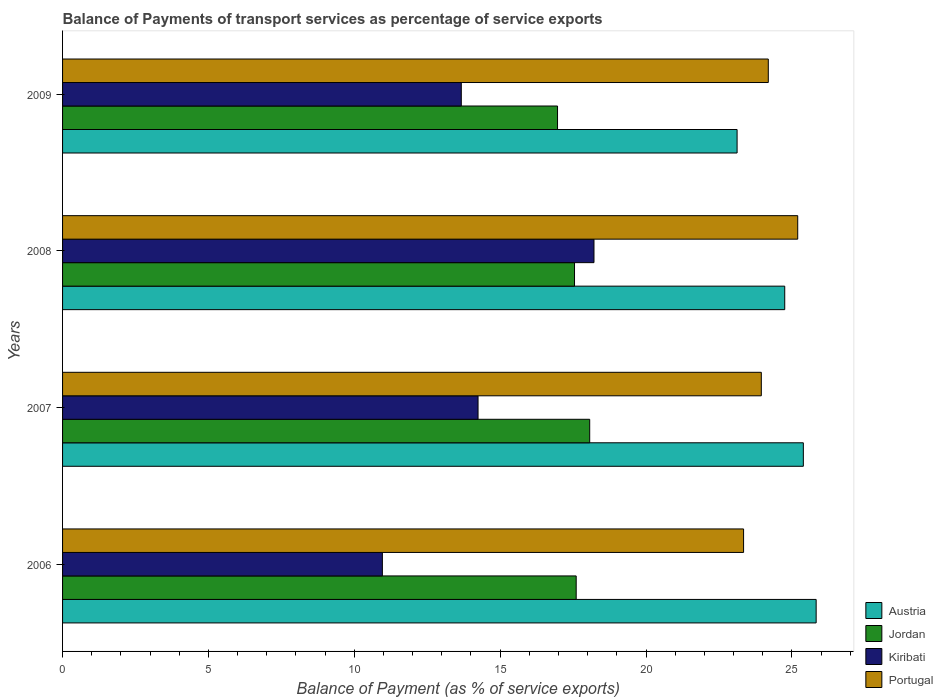Are the number of bars per tick equal to the number of legend labels?
Keep it short and to the point. Yes. Are the number of bars on each tick of the Y-axis equal?
Provide a short and direct response. Yes. How many bars are there on the 3rd tick from the top?
Give a very brief answer. 4. How many bars are there on the 4th tick from the bottom?
Ensure brevity in your answer.  4. What is the label of the 3rd group of bars from the top?
Make the answer very short. 2007. In how many cases, is the number of bars for a given year not equal to the number of legend labels?
Your answer should be compact. 0. What is the balance of payments of transport services in Jordan in 2006?
Provide a succinct answer. 17.61. Across all years, what is the maximum balance of payments of transport services in Austria?
Ensure brevity in your answer.  25.83. Across all years, what is the minimum balance of payments of transport services in Jordan?
Make the answer very short. 16.97. In which year was the balance of payments of transport services in Portugal minimum?
Keep it short and to the point. 2006. What is the total balance of payments of transport services in Portugal in the graph?
Ensure brevity in your answer.  96.69. What is the difference between the balance of payments of transport services in Jordan in 2006 and that in 2008?
Keep it short and to the point. 0.06. What is the difference between the balance of payments of transport services in Austria in 2006 and the balance of payments of transport services in Kiribati in 2007?
Provide a short and direct response. 11.59. What is the average balance of payments of transport services in Jordan per year?
Provide a short and direct response. 17.55. In the year 2009, what is the difference between the balance of payments of transport services in Jordan and balance of payments of transport services in Portugal?
Make the answer very short. -7.22. What is the ratio of the balance of payments of transport services in Kiribati in 2006 to that in 2009?
Give a very brief answer. 0.8. Is the difference between the balance of payments of transport services in Jordan in 2008 and 2009 greater than the difference between the balance of payments of transport services in Portugal in 2008 and 2009?
Make the answer very short. No. What is the difference between the highest and the second highest balance of payments of transport services in Jordan?
Your answer should be very brief. 0.46. What is the difference between the highest and the lowest balance of payments of transport services in Portugal?
Ensure brevity in your answer.  1.86. Is it the case that in every year, the sum of the balance of payments of transport services in Portugal and balance of payments of transport services in Austria is greater than the sum of balance of payments of transport services in Jordan and balance of payments of transport services in Kiribati?
Provide a succinct answer. No. What does the 1st bar from the top in 2008 represents?
Your response must be concise. Portugal. What does the 3rd bar from the bottom in 2008 represents?
Your answer should be compact. Kiribati. Is it the case that in every year, the sum of the balance of payments of transport services in Austria and balance of payments of transport services in Jordan is greater than the balance of payments of transport services in Kiribati?
Give a very brief answer. Yes. How many bars are there?
Offer a terse response. 16. Are all the bars in the graph horizontal?
Make the answer very short. Yes. What is the difference between two consecutive major ticks on the X-axis?
Your answer should be compact. 5. Where does the legend appear in the graph?
Your answer should be compact. Bottom right. How are the legend labels stacked?
Your answer should be very brief. Vertical. What is the title of the graph?
Provide a short and direct response. Balance of Payments of transport services as percentage of service exports. Does "Sao Tome and Principe" appear as one of the legend labels in the graph?
Your answer should be compact. No. What is the label or title of the X-axis?
Offer a very short reply. Balance of Payment (as % of service exports). What is the Balance of Payment (as % of service exports) in Austria in 2006?
Offer a very short reply. 25.83. What is the Balance of Payment (as % of service exports) in Jordan in 2006?
Provide a short and direct response. 17.61. What is the Balance of Payment (as % of service exports) in Kiribati in 2006?
Provide a succinct answer. 10.96. What is the Balance of Payment (as % of service exports) of Portugal in 2006?
Your answer should be very brief. 23.34. What is the Balance of Payment (as % of service exports) of Austria in 2007?
Ensure brevity in your answer.  25.39. What is the Balance of Payment (as % of service exports) in Jordan in 2007?
Offer a very short reply. 18.07. What is the Balance of Payment (as % of service exports) in Kiribati in 2007?
Offer a terse response. 14.24. What is the Balance of Payment (as % of service exports) of Portugal in 2007?
Provide a short and direct response. 23.95. What is the Balance of Payment (as % of service exports) of Austria in 2008?
Offer a terse response. 24.75. What is the Balance of Payment (as % of service exports) in Jordan in 2008?
Give a very brief answer. 17.55. What is the Balance of Payment (as % of service exports) in Kiribati in 2008?
Your answer should be compact. 18.22. What is the Balance of Payment (as % of service exports) of Portugal in 2008?
Make the answer very short. 25.2. What is the Balance of Payment (as % of service exports) in Austria in 2009?
Offer a terse response. 23.12. What is the Balance of Payment (as % of service exports) in Jordan in 2009?
Provide a succinct answer. 16.97. What is the Balance of Payment (as % of service exports) in Kiribati in 2009?
Provide a short and direct response. 13.67. What is the Balance of Payment (as % of service exports) in Portugal in 2009?
Provide a succinct answer. 24.19. Across all years, what is the maximum Balance of Payment (as % of service exports) of Austria?
Ensure brevity in your answer.  25.83. Across all years, what is the maximum Balance of Payment (as % of service exports) of Jordan?
Your answer should be compact. 18.07. Across all years, what is the maximum Balance of Payment (as % of service exports) in Kiribati?
Ensure brevity in your answer.  18.22. Across all years, what is the maximum Balance of Payment (as % of service exports) in Portugal?
Keep it short and to the point. 25.2. Across all years, what is the minimum Balance of Payment (as % of service exports) in Austria?
Keep it short and to the point. 23.12. Across all years, what is the minimum Balance of Payment (as % of service exports) in Jordan?
Offer a terse response. 16.97. Across all years, what is the minimum Balance of Payment (as % of service exports) in Kiribati?
Ensure brevity in your answer.  10.96. Across all years, what is the minimum Balance of Payment (as % of service exports) in Portugal?
Make the answer very short. 23.34. What is the total Balance of Payment (as % of service exports) in Austria in the graph?
Keep it short and to the point. 99.1. What is the total Balance of Payment (as % of service exports) in Jordan in the graph?
Your answer should be compact. 70.19. What is the total Balance of Payment (as % of service exports) in Kiribati in the graph?
Ensure brevity in your answer.  57.09. What is the total Balance of Payment (as % of service exports) of Portugal in the graph?
Offer a very short reply. 96.69. What is the difference between the Balance of Payment (as % of service exports) of Austria in 2006 and that in 2007?
Your answer should be compact. 0.44. What is the difference between the Balance of Payment (as % of service exports) in Jordan in 2006 and that in 2007?
Make the answer very short. -0.46. What is the difference between the Balance of Payment (as % of service exports) in Kiribati in 2006 and that in 2007?
Keep it short and to the point. -3.28. What is the difference between the Balance of Payment (as % of service exports) in Portugal in 2006 and that in 2007?
Offer a terse response. -0.61. What is the difference between the Balance of Payment (as % of service exports) of Austria in 2006 and that in 2008?
Give a very brief answer. 1.08. What is the difference between the Balance of Payment (as % of service exports) of Jordan in 2006 and that in 2008?
Your answer should be compact. 0.06. What is the difference between the Balance of Payment (as % of service exports) of Kiribati in 2006 and that in 2008?
Provide a succinct answer. -7.25. What is the difference between the Balance of Payment (as % of service exports) of Portugal in 2006 and that in 2008?
Provide a succinct answer. -1.86. What is the difference between the Balance of Payment (as % of service exports) in Austria in 2006 and that in 2009?
Make the answer very short. 2.71. What is the difference between the Balance of Payment (as % of service exports) in Jordan in 2006 and that in 2009?
Provide a succinct answer. 0.64. What is the difference between the Balance of Payment (as % of service exports) in Kiribati in 2006 and that in 2009?
Offer a very short reply. -2.7. What is the difference between the Balance of Payment (as % of service exports) of Portugal in 2006 and that in 2009?
Ensure brevity in your answer.  -0.85. What is the difference between the Balance of Payment (as % of service exports) in Austria in 2007 and that in 2008?
Offer a very short reply. 0.64. What is the difference between the Balance of Payment (as % of service exports) in Jordan in 2007 and that in 2008?
Offer a terse response. 0.52. What is the difference between the Balance of Payment (as % of service exports) of Kiribati in 2007 and that in 2008?
Offer a terse response. -3.97. What is the difference between the Balance of Payment (as % of service exports) of Portugal in 2007 and that in 2008?
Ensure brevity in your answer.  -1.25. What is the difference between the Balance of Payment (as % of service exports) in Austria in 2007 and that in 2009?
Provide a succinct answer. 2.27. What is the difference between the Balance of Payment (as % of service exports) of Jordan in 2007 and that in 2009?
Your response must be concise. 1.1. What is the difference between the Balance of Payment (as % of service exports) in Kiribati in 2007 and that in 2009?
Keep it short and to the point. 0.57. What is the difference between the Balance of Payment (as % of service exports) of Portugal in 2007 and that in 2009?
Provide a short and direct response. -0.24. What is the difference between the Balance of Payment (as % of service exports) of Austria in 2008 and that in 2009?
Your answer should be compact. 1.63. What is the difference between the Balance of Payment (as % of service exports) in Jordan in 2008 and that in 2009?
Your answer should be compact. 0.58. What is the difference between the Balance of Payment (as % of service exports) in Kiribati in 2008 and that in 2009?
Ensure brevity in your answer.  4.55. What is the difference between the Balance of Payment (as % of service exports) in Portugal in 2008 and that in 2009?
Your answer should be very brief. 1.01. What is the difference between the Balance of Payment (as % of service exports) of Austria in 2006 and the Balance of Payment (as % of service exports) of Jordan in 2007?
Give a very brief answer. 7.76. What is the difference between the Balance of Payment (as % of service exports) in Austria in 2006 and the Balance of Payment (as % of service exports) in Kiribati in 2007?
Provide a short and direct response. 11.59. What is the difference between the Balance of Payment (as % of service exports) in Austria in 2006 and the Balance of Payment (as % of service exports) in Portugal in 2007?
Your response must be concise. 1.88. What is the difference between the Balance of Payment (as % of service exports) of Jordan in 2006 and the Balance of Payment (as % of service exports) of Kiribati in 2007?
Provide a succinct answer. 3.36. What is the difference between the Balance of Payment (as % of service exports) of Jordan in 2006 and the Balance of Payment (as % of service exports) of Portugal in 2007?
Provide a succinct answer. -6.35. What is the difference between the Balance of Payment (as % of service exports) of Kiribati in 2006 and the Balance of Payment (as % of service exports) of Portugal in 2007?
Your answer should be very brief. -12.99. What is the difference between the Balance of Payment (as % of service exports) in Austria in 2006 and the Balance of Payment (as % of service exports) in Jordan in 2008?
Offer a very short reply. 8.28. What is the difference between the Balance of Payment (as % of service exports) of Austria in 2006 and the Balance of Payment (as % of service exports) of Kiribati in 2008?
Offer a terse response. 7.62. What is the difference between the Balance of Payment (as % of service exports) of Austria in 2006 and the Balance of Payment (as % of service exports) of Portugal in 2008?
Provide a short and direct response. 0.63. What is the difference between the Balance of Payment (as % of service exports) in Jordan in 2006 and the Balance of Payment (as % of service exports) in Kiribati in 2008?
Provide a succinct answer. -0.61. What is the difference between the Balance of Payment (as % of service exports) of Jordan in 2006 and the Balance of Payment (as % of service exports) of Portugal in 2008?
Make the answer very short. -7.59. What is the difference between the Balance of Payment (as % of service exports) of Kiribati in 2006 and the Balance of Payment (as % of service exports) of Portugal in 2008?
Provide a succinct answer. -14.24. What is the difference between the Balance of Payment (as % of service exports) of Austria in 2006 and the Balance of Payment (as % of service exports) of Jordan in 2009?
Keep it short and to the point. 8.87. What is the difference between the Balance of Payment (as % of service exports) of Austria in 2006 and the Balance of Payment (as % of service exports) of Kiribati in 2009?
Your response must be concise. 12.16. What is the difference between the Balance of Payment (as % of service exports) of Austria in 2006 and the Balance of Payment (as % of service exports) of Portugal in 2009?
Offer a terse response. 1.64. What is the difference between the Balance of Payment (as % of service exports) in Jordan in 2006 and the Balance of Payment (as % of service exports) in Kiribati in 2009?
Offer a terse response. 3.94. What is the difference between the Balance of Payment (as % of service exports) in Jordan in 2006 and the Balance of Payment (as % of service exports) in Portugal in 2009?
Ensure brevity in your answer.  -6.58. What is the difference between the Balance of Payment (as % of service exports) of Kiribati in 2006 and the Balance of Payment (as % of service exports) of Portugal in 2009?
Offer a terse response. -13.23. What is the difference between the Balance of Payment (as % of service exports) in Austria in 2007 and the Balance of Payment (as % of service exports) in Jordan in 2008?
Make the answer very short. 7.84. What is the difference between the Balance of Payment (as % of service exports) of Austria in 2007 and the Balance of Payment (as % of service exports) of Kiribati in 2008?
Keep it short and to the point. 7.18. What is the difference between the Balance of Payment (as % of service exports) of Austria in 2007 and the Balance of Payment (as % of service exports) of Portugal in 2008?
Offer a very short reply. 0.19. What is the difference between the Balance of Payment (as % of service exports) in Jordan in 2007 and the Balance of Payment (as % of service exports) in Kiribati in 2008?
Offer a terse response. -0.15. What is the difference between the Balance of Payment (as % of service exports) in Jordan in 2007 and the Balance of Payment (as % of service exports) in Portugal in 2008?
Your answer should be compact. -7.13. What is the difference between the Balance of Payment (as % of service exports) in Kiribati in 2007 and the Balance of Payment (as % of service exports) in Portugal in 2008?
Give a very brief answer. -10.96. What is the difference between the Balance of Payment (as % of service exports) of Austria in 2007 and the Balance of Payment (as % of service exports) of Jordan in 2009?
Make the answer very short. 8.43. What is the difference between the Balance of Payment (as % of service exports) in Austria in 2007 and the Balance of Payment (as % of service exports) in Kiribati in 2009?
Your response must be concise. 11.72. What is the difference between the Balance of Payment (as % of service exports) of Austria in 2007 and the Balance of Payment (as % of service exports) of Portugal in 2009?
Your answer should be very brief. 1.2. What is the difference between the Balance of Payment (as % of service exports) in Jordan in 2007 and the Balance of Payment (as % of service exports) in Kiribati in 2009?
Ensure brevity in your answer.  4.4. What is the difference between the Balance of Payment (as % of service exports) of Jordan in 2007 and the Balance of Payment (as % of service exports) of Portugal in 2009?
Offer a terse response. -6.12. What is the difference between the Balance of Payment (as % of service exports) in Kiribati in 2007 and the Balance of Payment (as % of service exports) in Portugal in 2009?
Your response must be concise. -9.95. What is the difference between the Balance of Payment (as % of service exports) of Austria in 2008 and the Balance of Payment (as % of service exports) of Jordan in 2009?
Provide a succinct answer. 7.79. What is the difference between the Balance of Payment (as % of service exports) in Austria in 2008 and the Balance of Payment (as % of service exports) in Kiribati in 2009?
Provide a succinct answer. 11.09. What is the difference between the Balance of Payment (as % of service exports) of Austria in 2008 and the Balance of Payment (as % of service exports) of Portugal in 2009?
Ensure brevity in your answer.  0.56. What is the difference between the Balance of Payment (as % of service exports) in Jordan in 2008 and the Balance of Payment (as % of service exports) in Kiribati in 2009?
Ensure brevity in your answer.  3.88. What is the difference between the Balance of Payment (as % of service exports) in Jordan in 2008 and the Balance of Payment (as % of service exports) in Portugal in 2009?
Offer a terse response. -6.64. What is the difference between the Balance of Payment (as % of service exports) in Kiribati in 2008 and the Balance of Payment (as % of service exports) in Portugal in 2009?
Your answer should be compact. -5.98. What is the average Balance of Payment (as % of service exports) of Austria per year?
Ensure brevity in your answer.  24.78. What is the average Balance of Payment (as % of service exports) in Jordan per year?
Your response must be concise. 17.55. What is the average Balance of Payment (as % of service exports) in Kiribati per year?
Your answer should be compact. 14.27. What is the average Balance of Payment (as % of service exports) of Portugal per year?
Give a very brief answer. 24.17. In the year 2006, what is the difference between the Balance of Payment (as % of service exports) of Austria and Balance of Payment (as % of service exports) of Jordan?
Make the answer very short. 8.23. In the year 2006, what is the difference between the Balance of Payment (as % of service exports) in Austria and Balance of Payment (as % of service exports) in Kiribati?
Make the answer very short. 14.87. In the year 2006, what is the difference between the Balance of Payment (as % of service exports) in Austria and Balance of Payment (as % of service exports) in Portugal?
Make the answer very short. 2.49. In the year 2006, what is the difference between the Balance of Payment (as % of service exports) of Jordan and Balance of Payment (as % of service exports) of Kiribati?
Offer a very short reply. 6.64. In the year 2006, what is the difference between the Balance of Payment (as % of service exports) of Jordan and Balance of Payment (as % of service exports) of Portugal?
Keep it short and to the point. -5.74. In the year 2006, what is the difference between the Balance of Payment (as % of service exports) in Kiribati and Balance of Payment (as % of service exports) in Portugal?
Give a very brief answer. -12.38. In the year 2007, what is the difference between the Balance of Payment (as % of service exports) in Austria and Balance of Payment (as % of service exports) in Jordan?
Provide a short and direct response. 7.32. In the year 2007, what is the difference between the Balance of Payment (as % of service exports) of Austria and Balance of Payment (as % of service exports) of Kiribati?
Ensure brevity in your answer.  11.15. In the year 2007, what is the difference between the Balance of Payment (as % of service exports) in Austria and Balance of Payment (as % of service exports) in Portugal?
Provide a succinct answer. 1.44. In the year 2007, what is the difference between the Balance of Payment (as % of service exports) in Jordan and Balance of Payment (as % of service exports) in Kiribati?
Your answer should be very brief. 3.83. In the year 2007, what is the difference between the Balance of Payment (as % of service exports) of Jordan and Balance of Payment (as % of service exports) of Portugal?
Offer a very short reply. -5.88. In the year 2007, what is the difference between the Balance of Payment (as % of service exports) in Kiribati and Balance of Payment (as % of service exports) in Portugal?
Your answer should be very brief. -9.71. In the year 2008, what is the difference between the Balance of Payment (as % of service exports) of Austria and Balance of Payment (as % of service exports) of Jordan?
Keep it short and to the point. 7.21. In the year 2008, what is the difference between the Balance of Payment (as % of service exports) in Austria and Balance of Payment (as % of service exports) in Kiribati?
Your answer should be compact. 6.54. In the year 2008, what is the difference between the Balance of Payment (as % of service exports) in Austria and Balance of Payment (as % of service exports) in Portugal?
Your response must be concise. -0.45. In the year 2008, what is the difference between the Balance of Payment (as % of service exports) of Jordan and Balance of Payment (as % of service exports) of Kiribati?
Offer a terse response. -0.67. In the year 2008, what is the difference between the Balance of Payment (as % of service exports) of Jordan and Balance of Payment (as % of service exports) of Portugal?
Offer a terse response. -7.65. In the year 2008, what is the difference between the Balance of Payment (as % of service exports) in Kiribati and Balance of Payment (as % of service exports) in Portugal?
Provide a succinct answer. -6.98. In the year 2009, what is the difference between the Balance of Payment (as % of service exports) of Austria and Balance of Payment (as % of service exports) of Jordan?
Provide a succinct answer. 6.15. In the year 2009, what is the difference between the Balance of Payment (as % of service exports) in Austria and Balance of Payment (as % of service exports) in Kiribati?
Give a very brief answer. 9.45. In the year 2009, what is the difference between the Balance of Payment (as % of service exports) of Austria and Balance of Payment (as % of service exports) of Portugal?
Offer a terse response. -1.07. In the year 2009, what is the difference between the Balance of Payment (as % of service exports) of Jordan and Balance of Payment (as % of service exports) of Kiribati?
Offer a very short reply. 3.3. In the year 2009, what is the difference between the Balance of Payment (as % of service exports) in Jordan and Balance of Payment (as % of service exports) in Portugal?
Provide a succinct answer. -7.22. In the year 2009, what is the difference between the Balance of Payment (as % of service exports) of Kiribati and Balance of Payment (as % of service exports) of Portugal?
Your response must be concise. -10.52. What is the ratio of the Balance of Payment (as % of service exports) of Austria in 2006 to that in 2007?
Give a very brief answer. 1.02. What is the ratio of the Balance of Payment (as % of service exports) in Jordan in 2006 to that in 2007?
Your response must be concise. 0.97. What is the ratio of the Balance of Payment (as % of service exports) in Kiribati in 2006 to that in 2007?
Keep it short and to the point. 0.77. What is the ratio of the Balance of Payment (as % of service exports) in Portugal in 2006 to that in 2007?
Offer a terse response. 0.97. What is the ratio of the Balance of Payment (as % of service exports) in Austria in 2006 to that in 2008?
Make the answer very short. 1.04. What is the ratio of the Balance of Payment (as % of service exports) in Kiribati in 2006 to that in 2008?
Make the answer very short. 0.6. What is the ratio of the Balance of Payment (as % of service exports) of Portugal in 2006 to that in 2008?
Give a very brief answer. 0.93. What is the ratio of the Balance of Payment (as % of service exports) of Austria in 2006 to that in 2009?
Make the answer very short. 1.12. What is the ratio of the Balance of Payment (as % of service exports) in Jordan in 2006 to that in 2009?
Your response must be concise. 1.04. What is the ratio of the Balance of Payment (as % of service exports) of Kiribati in 2006 to that in 2009?
Make the answer very short. 0.8. What is the ratio of the Balance of Payment (as % of service exports) in Portugal in 2006 to that in 2009?
Provide a short and direct response. 0.96. What is the ratio of the Balance of Payment (as % of service exports) in Austria in 2007 to that in 2008?
Provide a short and direct response. 1.03. What is the ratio of the Balance of Payment (as % of service exports) of Jordan in 2007 to that in 2008?
Give a very brief answer. 1.03. What is the ratio of the Balance of Payment (as % of service exports) in Kiribati in 2007 to that in 2008?
Your answer should be very brief. 0.78. What is the ratio of the Balance of Payment (as % of service exports) in Portugal in 2007 to that in 2008?
Provide a short and direct response. 0.95. What is the ratio of the Balance of Payment (as % of service exports) of Austria in 2007 to that in 2009?
Offer a very short reply. 1.1. What is the ratio of the Balance of Payment (as % of service exports) in Jordan in 2007 to that in 2009?
Provide a succinct answer. 1.06. What is the ratio of the Balance of Payment (as % of service exports) of Kiribati in 2007 to that in 2009?
Your answer should be very brief. 1.04. What is the ratio of the Balance of Payment (as % of service exports) in Portugal in 2007 to that in 2009?
Provide a short and direct response. 0.99. What is the ratio of the Balance of Payment (as % of service exports) in Austria in 2008 to that in 2009?
Give a very brief answer. 1.07. What is the ratio of the Balance of Payment (as % of service exports) of Jordan in 2008 to that in 2009?
Offer a terse response. 1.03. What is the ratio of the Balance of Payment (as % of service exports) in Kiribati in 2008 to that in 2009?
Offer a terse response. 1.33. What is the ratio of the Balance of Payment (as % of service exports) in Portugal in 2008 to that in 2009?
Provide a succinct answer. 1.04. What is the difference between the highest and the second highest Balance of Payment (as % of service exports) of Austria?
Keep it short and to the point. 0.44. What is the difference between the highest and the second highest Balance of Payment (as % of service exports) in Jordan?
Provide a short and direct response. 0.46. What is the difference between the highest and the second highest Balance of Payment (as % of service exports) in Kiribati?
Provide a short and direct response. 3.97. What is the difference between the highest and the second highest Balance of Payment (as % of service exports) of Portugal?
Give a very brief answer. 1.01. What is the difference between the highest and the lowest Balance of Payment (as % of service exports) of Austria?
Your answer should be compact. 2.71. What is the difference between the highest and the lowest Balance of Payment (as % of service exports) in Jordan?
Provide a short and direct response. 1.1. What is the difference between the highest and the lowest Balance of Payment (as % of service exports) in Kiribati?
Make the answer very short. 7.25. What is the difference between the highest and the lowest Balance of Payment (as % of service exports) in Portugal?
Offer a very short reply. 1.86. 